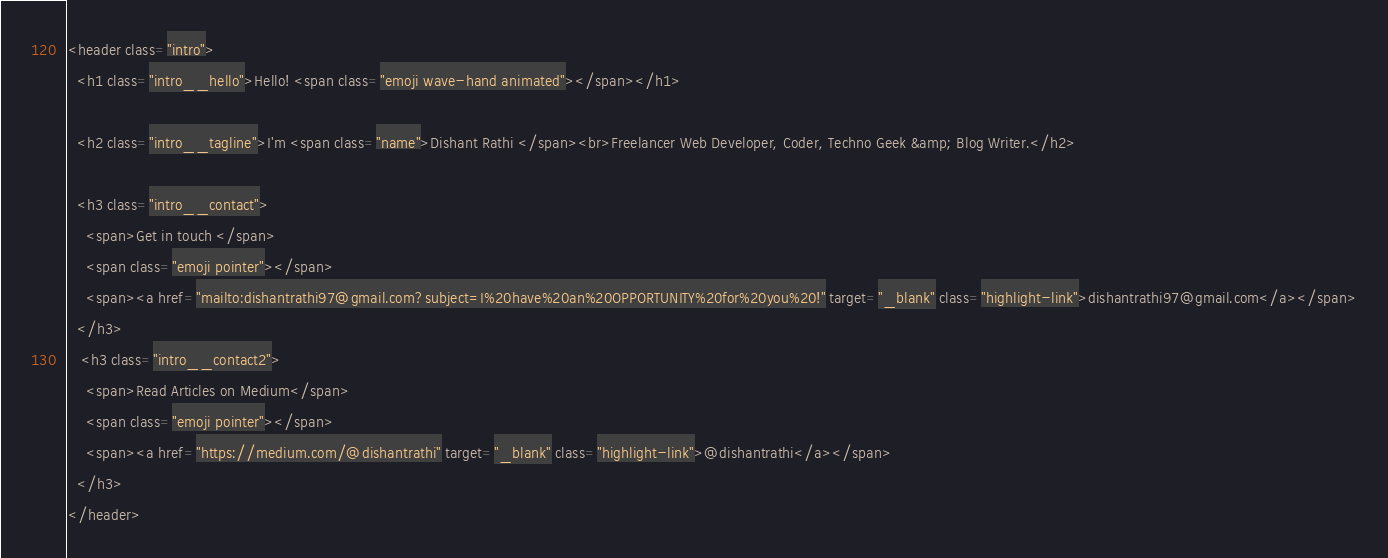Convert code to text. <code><loc_0><loc_0><loc_500><loc_500><_HTML_><header class="intro">
  <h1 class="intro__hello">Hello! <span class="emoji wave-hand animated"></span></h1>

  <h2 class="intro__tagline">I'm <span class="name">Dishant Rathi </span><br>Freelancer Web Developer, Coder, Techno Geek &amp; Blog Writer.</h2>

  <h3 class="intro__contact">
    <span>Get in touch </span>
    <span class="emoji pointer"></span>
    <span><a href="mailto:dishantrathi97@gmail.com?subject=I%20have%20an%20OPPORTUNITY%20for%20you%20!" target="_blank" class="highlight-link">dishantrathi97@gmail.com</a></span>
  </h3>
   <h3 class="intro__contact2">
    <span>Read Articles on Medium</span>
    <span class="emoji pointer"></span>
    <span><a href="https://medium.com/@dishantrathi" target="_blank" class="highlight-link">@dishantrathi</a></span>
  </h3>
</header>
</code> 